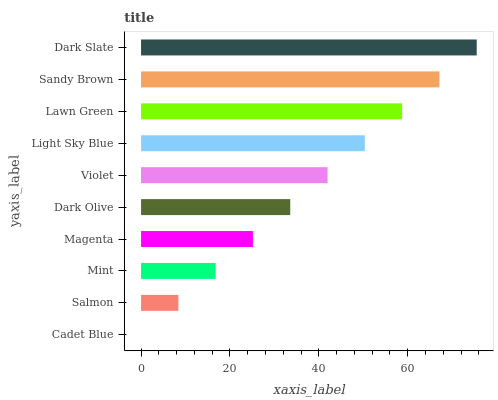Is Cadet Blue the minimum?
Answer yes or no. Yes. Is Dark Slate the maximum?
Answer yes or no. Yes. Is Salmon the minimum?
Answer yes or no. No. Is Salmon the maximum?
Answer yes or no. No. Is Salmon greater than Cadet Blue?
Answer yes or no. Yes. Is Cadet Blue less than Salmon?
Answer yes or no. Yes. Is Cadet Blue greater than Salmon?
Answer yes or no. No. Is Salmon less than Cadet Blue?
Answer yes or no. No. Is Violet the high median?
Answer yes or no. Yes. Is Dark Olive the low median?
Answer yes or no. Yes. Is Magenta the high median?
Answer yes or no. No. Is Dark Slate the low median?
Answer yes or no. No. 